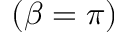<formula> <loc_0><loc_0><loc_500><loc_500>( \beta = \pi )</formula> 